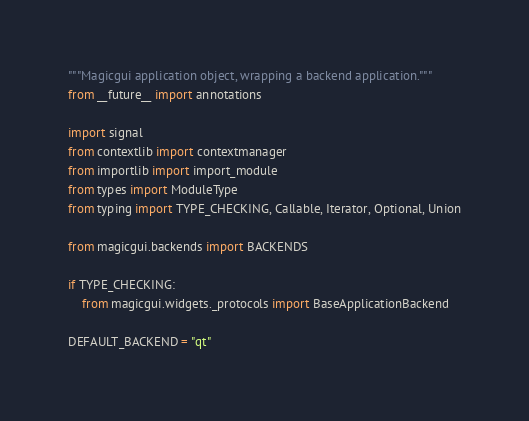<code> <loc_0><loc_0><loc_500><loc_500><_Python_>"""Magicgui application object, wrapping a backend application."""
from __future__ import annotations

import signal
from contextlib import contextmanager
from importlib import import_module
from types import ModuleType
from typing import TYPE_CHECKING, Callable, Iterator, Optional, Union

from magicgui.backends import BACKENDS

if TYPE_CHECKING:
    from magicgui.widgets._protocols import BaseApplicationBackend

DEFAULT_BACKEND = "qt"</code> 